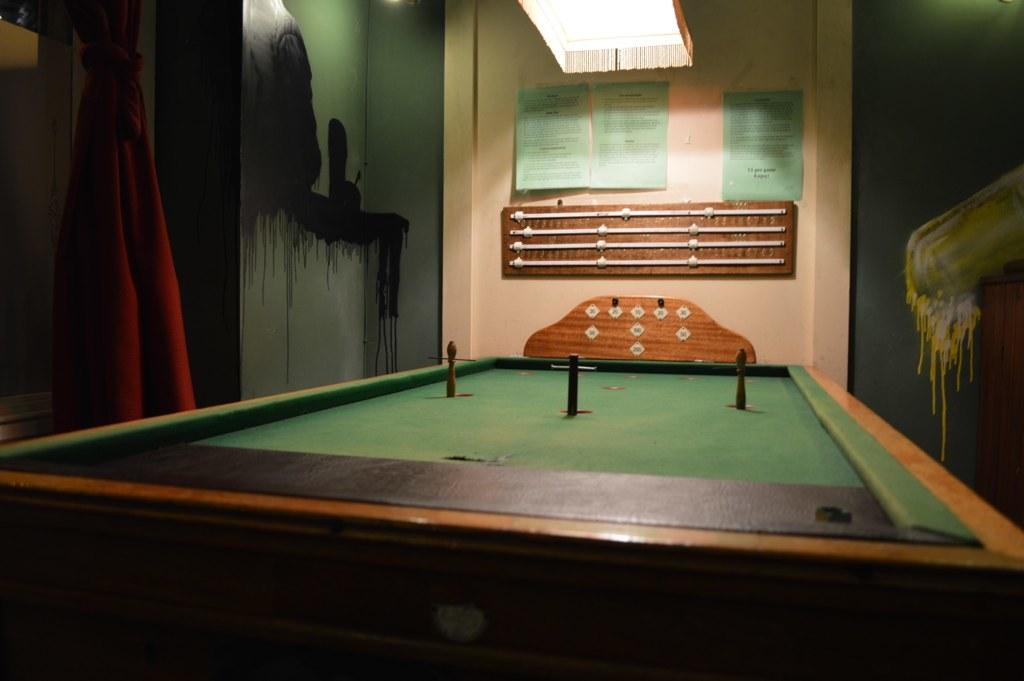What type of furniture is present in the image? There is a table in the image. How many books are stacked on the stone in the image? There is no stone or books present in the image; only a table is mentioned. 